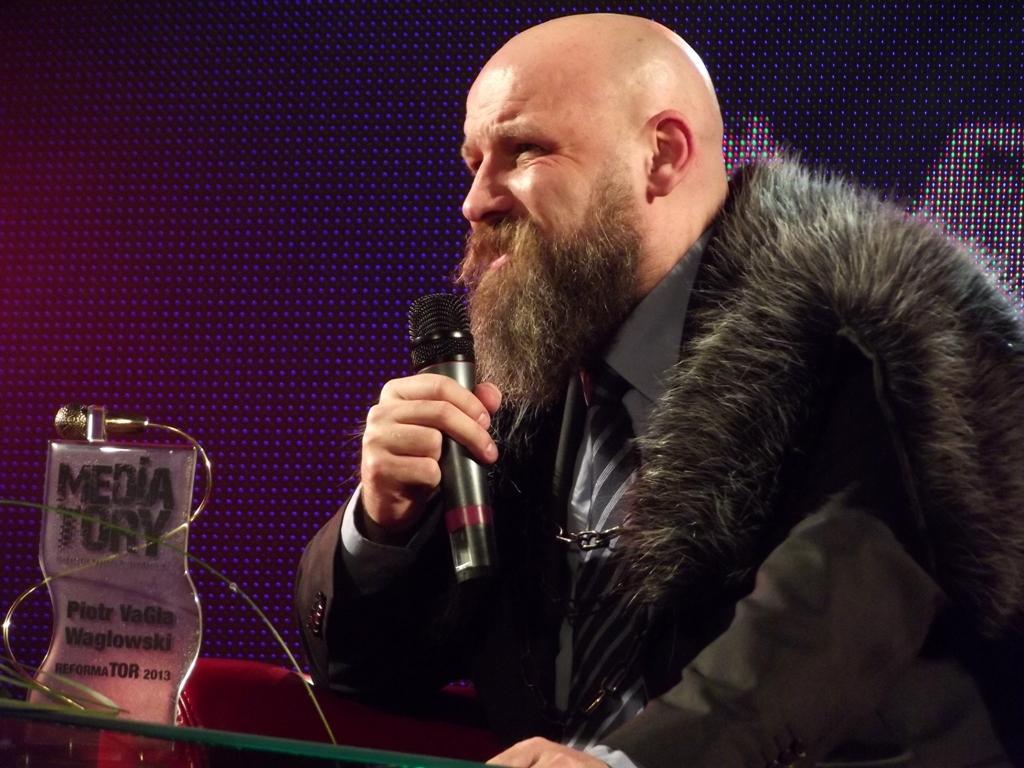Please provide a concise description of this image. In this image I can see the person wearing the dress and holding the mic. In-front of the person I can see the glass board on the podium. I can see there is a black and purple color background. 